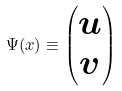Convert formula to latex. <formula><loc_0><loc_0><loc_500><loc_500>\Psi ( x ) \equiv \begin{pmatrix} u \\ v \end{pmatrix}</formula> 